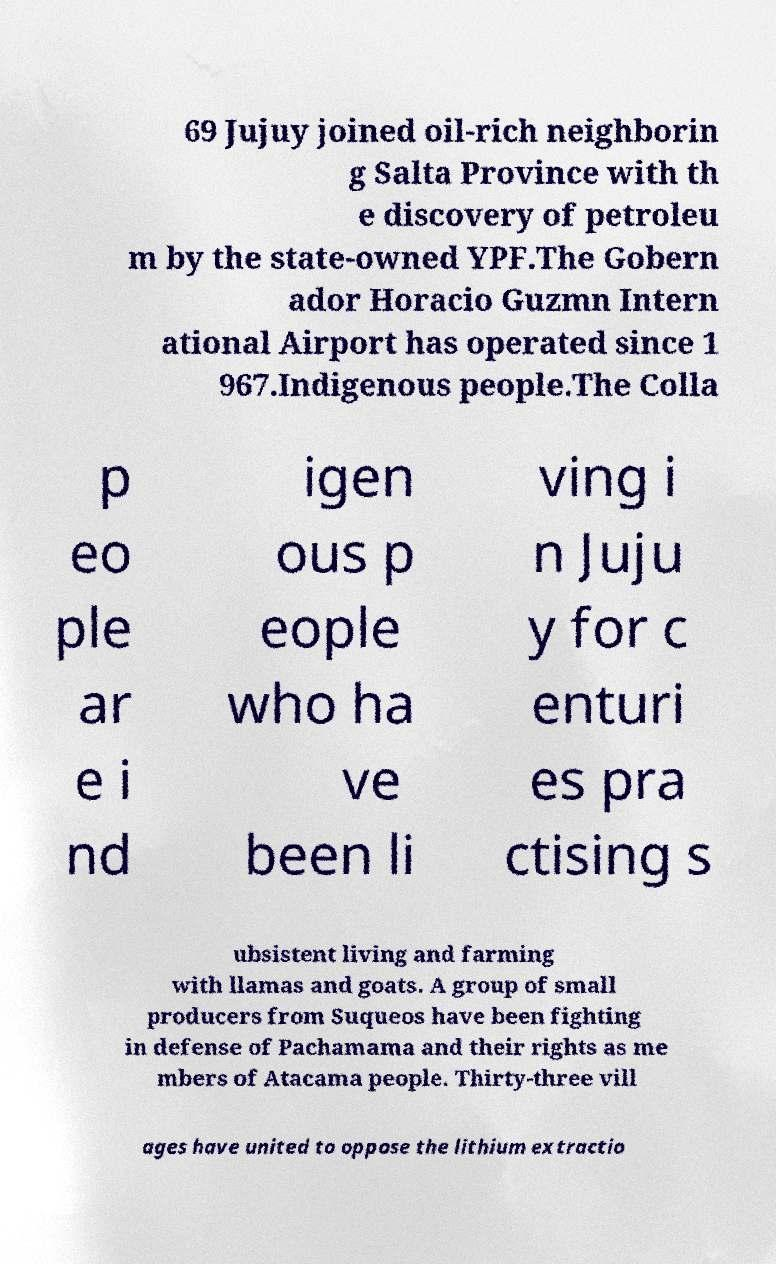What messages or text are displayed in this image? I need them in a readable, typed format. 69 Jujuy joined oil-rich neighborin g Salta Province with th e discovery of petroleu m by the state-owned YPF.The Gobern ador Horacio Guzmn Intern ational Airport has operated since 1 967.Indigenous people.The Colla p eo ple ar e i nd igen ous p eople who ha ve been li ving i n Juju y for c enturi es pra ctising s ubsistent living and farming with llamas and goats. A group of small producers from Suqueos have been fighting in defense of Pachamama and their rights as me mbers of Atacama people. Thirty-three vill ages have united to oppose the lithium extractio 